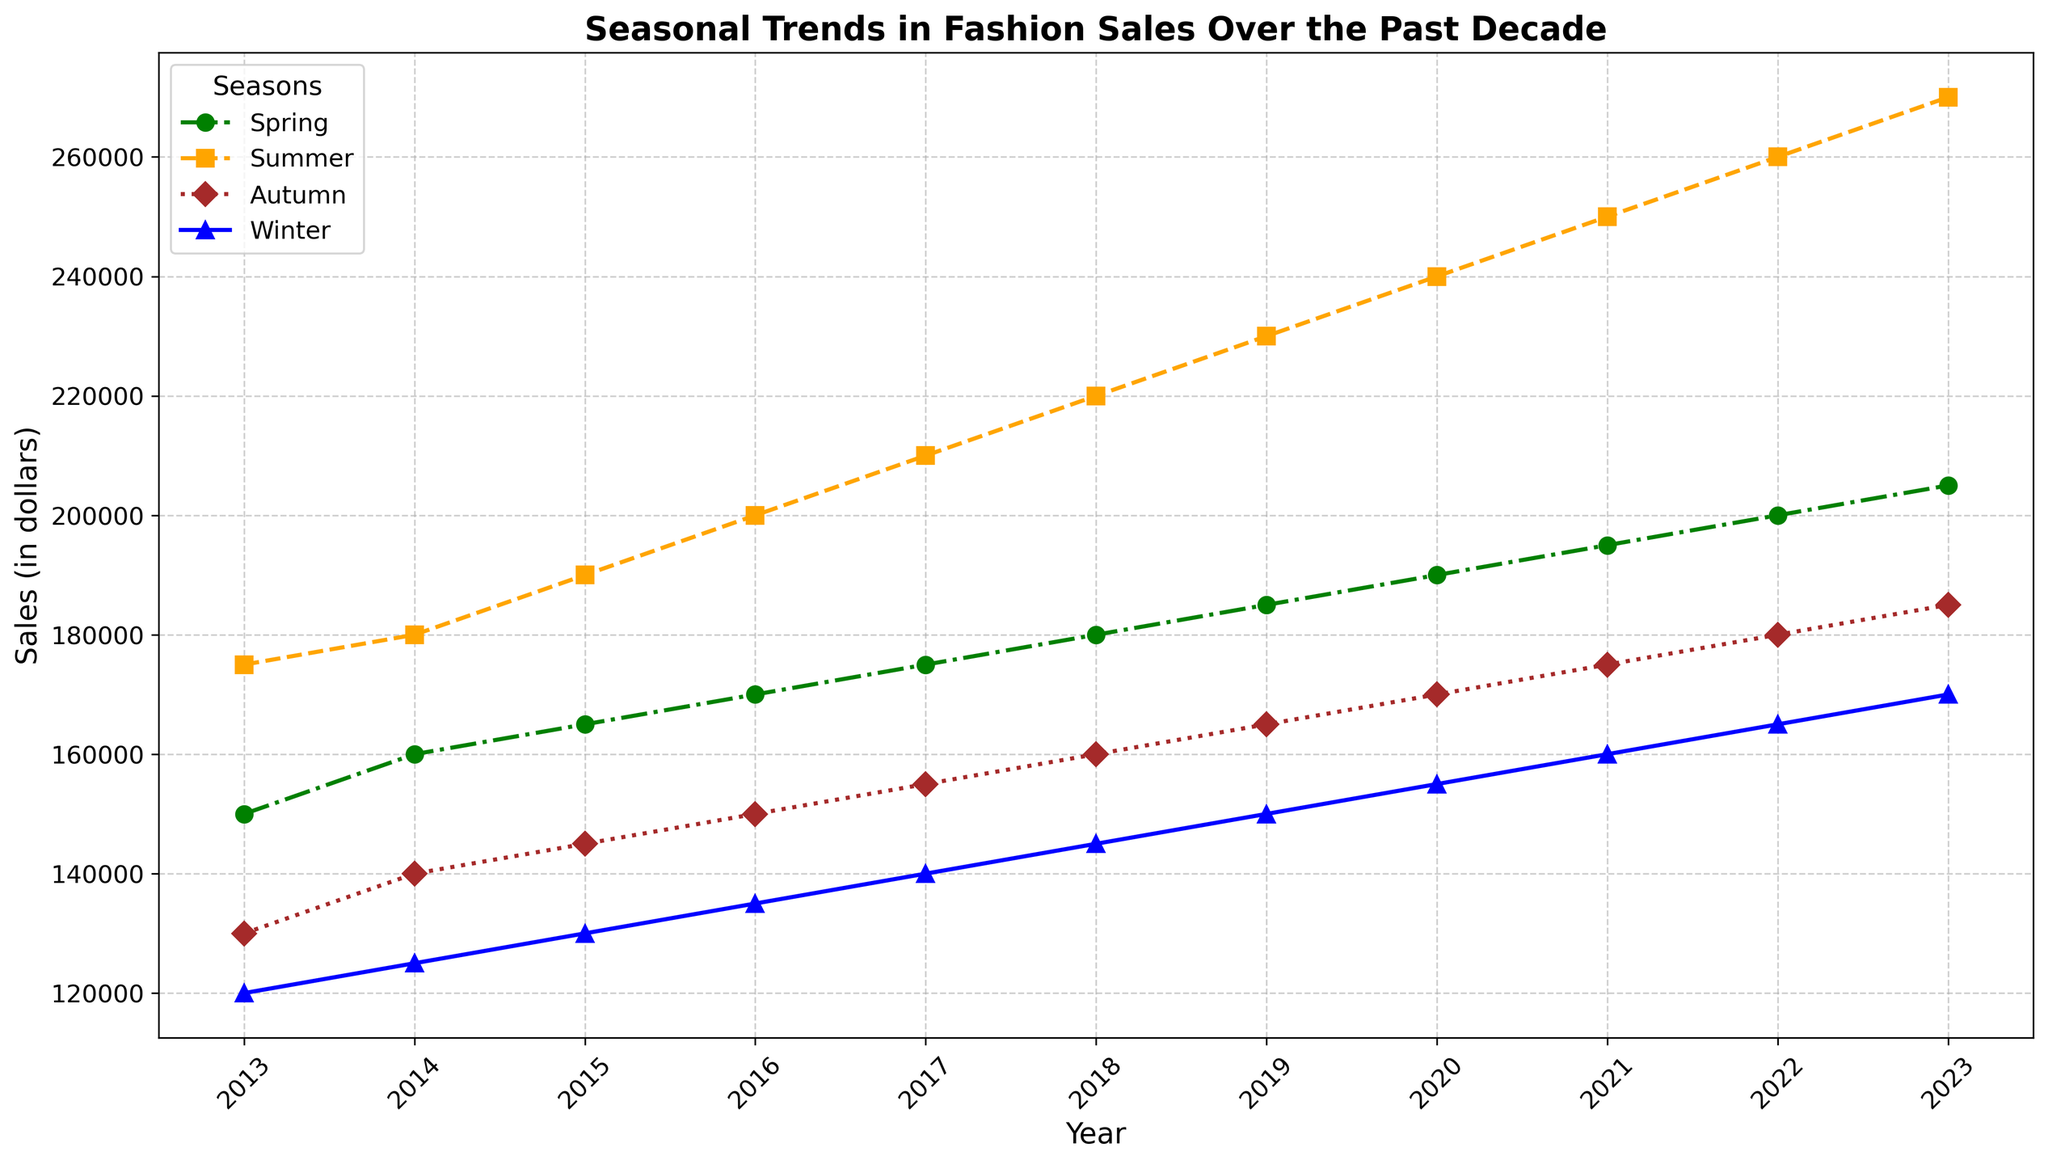Which season saw the highest sales in 2023? The plot shows a clear peak for each season's line in 2023. The highest line in 2023 corresponds to Summer.
Answer: Summer Throughout the decade, which season consistently had lower sales than the others? By visually comparing the lines for Spring, Summer, Autumn, and Winter over the years, Winter consistently appears lower than the other seasons throughout the decade.
Answer: Winter What is the difference in Winter sales between 2023 and 2013? Look for the Winter sales points in 2023 and 2013. In 2023 Winter sales are 170,000 and in 2013 Winter sales are 120,000. Then 170,000 - 120,000 = 50,000
Answer: 50,000 Which year shows the smallest difference in sales between Spring and Summer? To find the smallest difference, check the vertical distance between the Spring and Summer lines for each year. The smallest difference visually appears in 2014, where Spring had 160,000 and Summer had 180,000. So, the difference is 20,000.
Answer: 2014 On average, how did Autumn sales change each year from 2013 to 2023? Find the Autumn sales for each year from the plot, sum them up and then find the average yearly change. Sales are: 130,000, 140,000, 145,000, 150,000, 155,000, 160,000, 165,000, 170,000, 175,000, 180,000, 185,000. The differences are: 10,000 each year, so the average is 10,000.
Answer: Increased by 10,000 per year Which season had the most consistent sales growth over the decade? By visually tracking the lines, Summer shows the most consistent and steep upward trend over the decade, indicating consistent growth.
Answer: Summer In which year did Spring sales surpass Winter sales by the largest margin? Visually compare the gap between Spring and Winter lines each year. The largest gap appears in 2023 where Spring sales are 205,000 and Winter sales are 170,000. The difference is 35,000.
Answer: 2023 How many years did the Autumn sales exceed 150,000? Visually inspect the Autumn line and count the number of years the sales points are above 150,000. The years are 2017 to 2023, totaling 7 years.
Answer: 7 What was the combined sales for all seasons in 2020? Sum the sales for each season in 2020: Spring 190,000, Summer 240,000, Autumn 170,000, Winter 155,000. The sum is 190,000 + 240,000 + 170,000 + 155,000 = 755,000.
Answer: 755,000 Compare the sales trend between Spring and Autumn from 2013 to 2023. Which season had a greater range in sales values? Check the highest and lowest points for both Spring and Autumn. Spring ranges from 150,000 to 205,000 and Autumn ranges from 130,000 to 185,000. Spring's range is 55,000 while Autumn's is 55,000, so they are equal.
Answer: Equal 